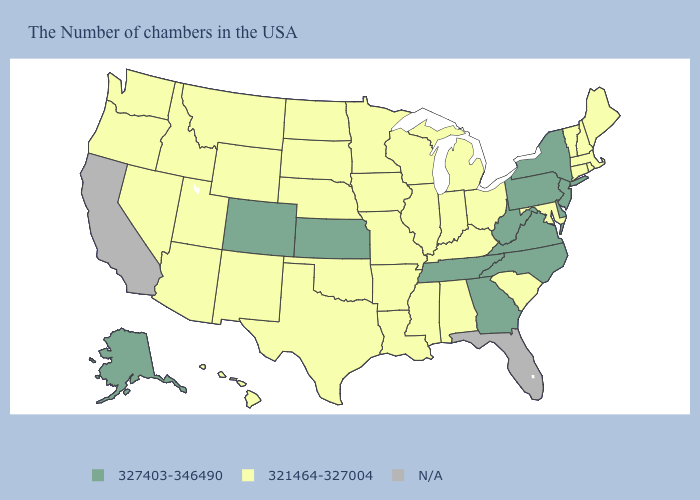What is the value of Hawaii?
Be succinct. 321464-327004. What is the value of Illinois?
Give a very brief answer. 321464-327004. Name the states that have a value in the range N/A?
Answer briefly. Florida, California. What is the value of Washington?
Answer briefly. 321464-327004. Name the states that have a value in the range N/A?
Quick response, please. Florida, California. What is the highest value in the USA?
Concise answer only. 327403-346490. Among the states that border Alabama , does Tennessee have the highest value?
Quick response, please. Yes. Among the states that border Illinois , which have the lowest value?
Write a very short answer. Kentucky, Indiana, Wisconsin, Missouri, Iowa. Does Michigan have the highest value in the MidWest?
Give a very brief answer. No. What is the highest value in states that border Iowa?
Quick response, please. 321464-327004. What is the highest value in the USA?
Answer briefly. 327403-346490. Among the states that border Vermont , which have the lowest value?
Give a very brief answer. Massachusetts, New Hampshire. Does Virginia have the highest value in the USA?
Write a very short answer. Yes. Name the states that have a value in the range 321464-327004?
Keep it brief. Maine, Massachusetts, Rhode Island, New Hampshire, Vermont, Connecticut, Maryland, South Carolina, Ohio, Michigan, Kentucky, Indiana, Alabama, Wisconsin, Illinois, Mississippi, Louisiana, Missouri, Arkansas, Minnesota, Iowa, Nebraska, Oklahoma, Texas, South Dakota, North Dakota, Wyoming, New Mexico, Utah, Montana, Arizona, Idaho, Nevada, Washington, Oregon, Hawaii. 